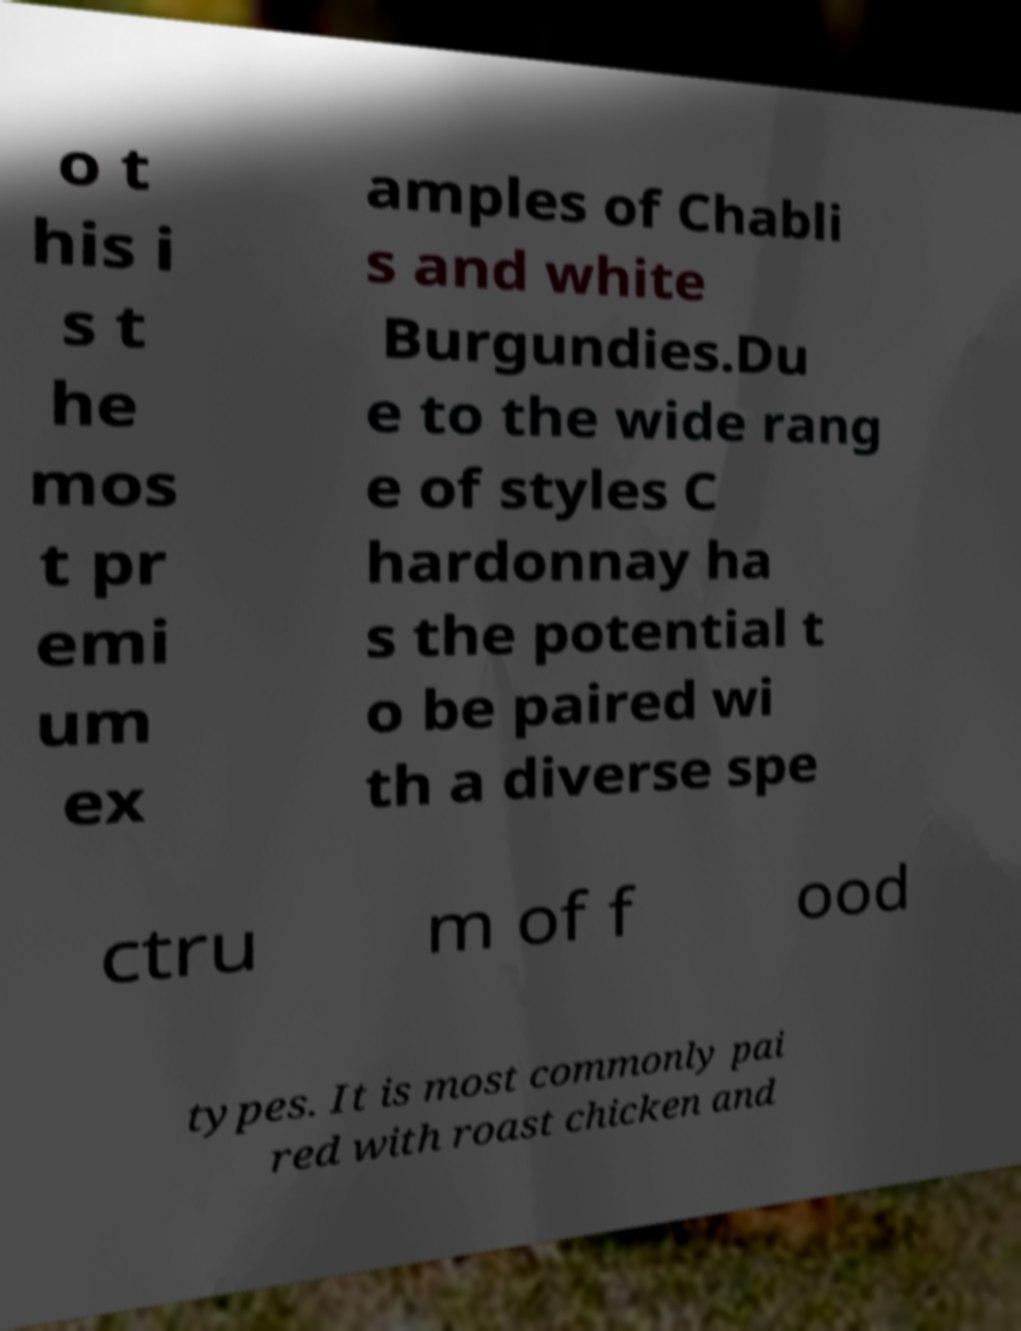Can you accurately transcribe the text from the provided image for me? o t his i s t he mos t pr emi um ex amples of Chabli s and white Burgundies.Du e to the wide rang e of styles C hardonnay ha s the potential t o be paired wi th a diverse spe ctru m of f ood types. It is most commonly pai red with roast chicken and 